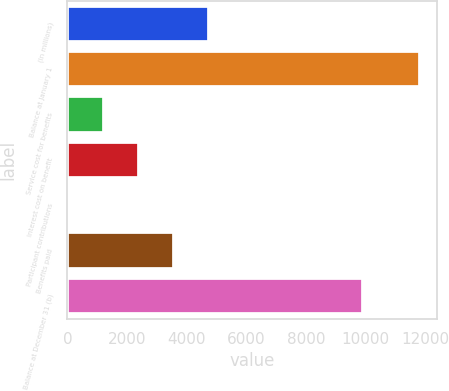Convert chart to OTSL. <chart><loc_0><loc_0><loc_500><loc_500><bar_chart><fcel>(In millions)<fcel>Balance at January 1<fcel>Service cost for benefits<fcel>Interest cost on benefit<fcel>Participant contributions<fcel>Benefits paid<fcel>Balance at December 31 (b)<nl><fcel>4752.8<fcel>11804<fcel>1227.2<fcel>2402.4<fcel>52<fcel>3577.6<fcel>9913<nl></chart> 